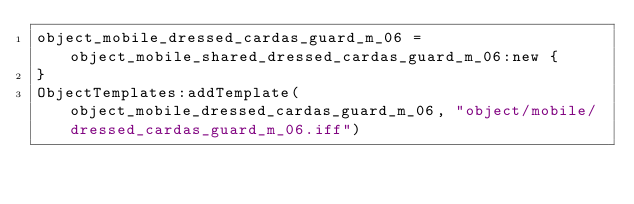<code> <loc_0><loc_0><loc_500><loc_500><_Lua_>object_mobile_dressed_cardas_guard_m_06 = object_mobile_shared_dressed_cardas_guard_m_06:new {
}
ObjectTemplates:addTemplate(object_mobile_dressed_cardas_guard_m_06, "object/mobile/dressed_cardas_guard_m_06.iff")
</code> 